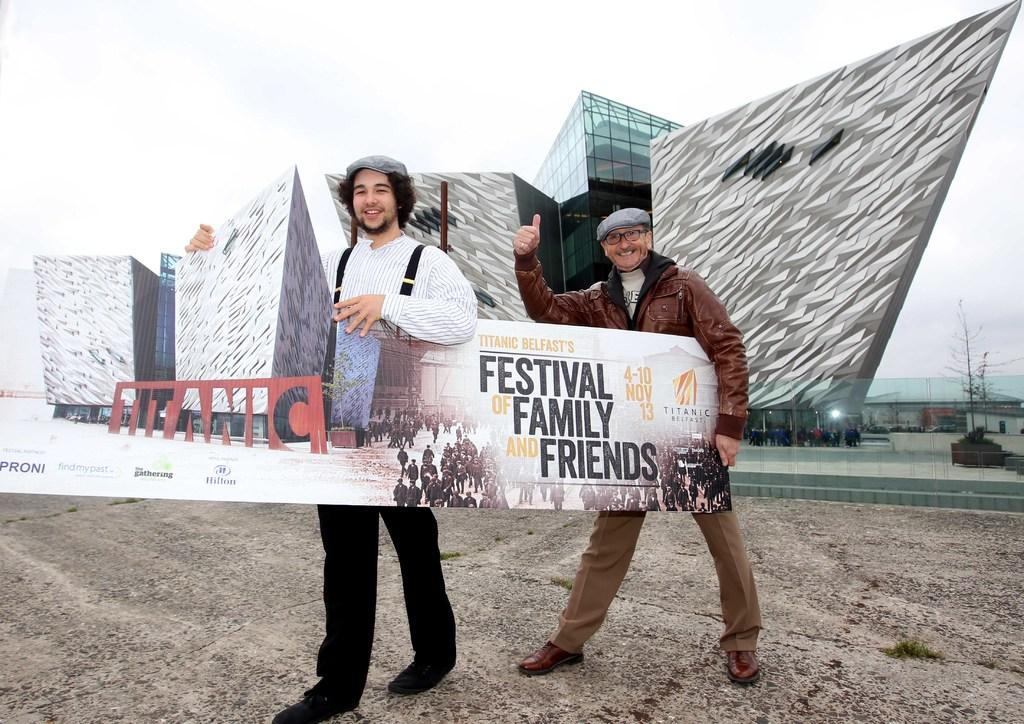How many people are in the image? There are two men in the image. What are the men holding in the image? The men are holding a board. What is the facial expression of the men in the image? The men are smiling. What can be seen in the background of the image? There is a huge building in the background of the image. What type of butter can be seen on the boat in the image? There is no boat or butter present in the image. How many bananas are being held by the men in the image? There are no bananas visible in the image; the men are holding a board. 